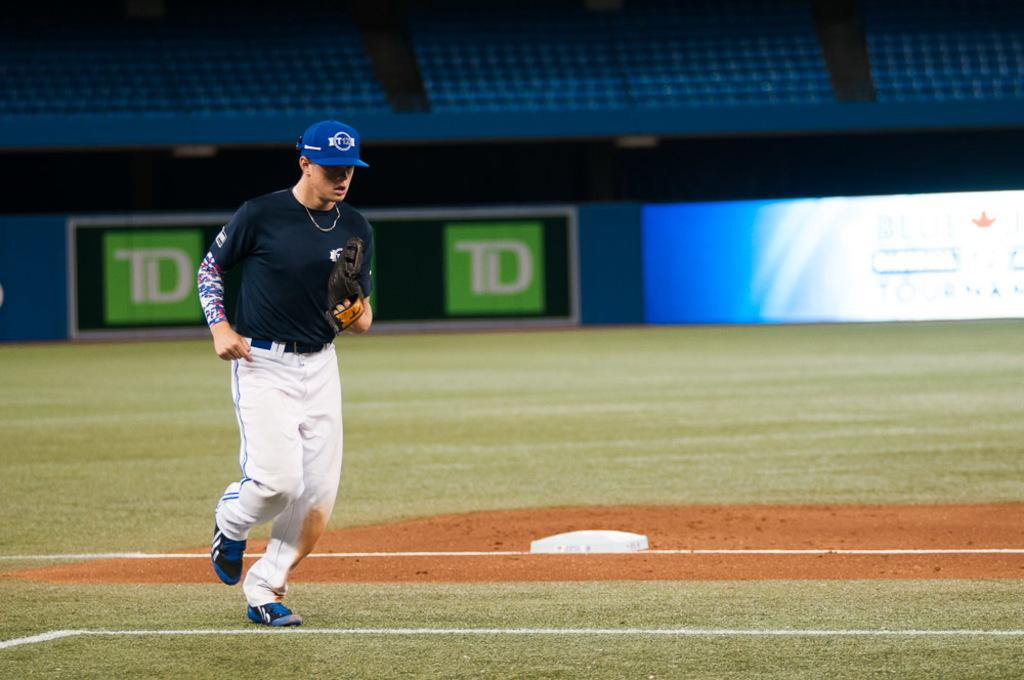<image>
Create a compact narrative representing the image presented. a baseball player runs on a field with TD on it 